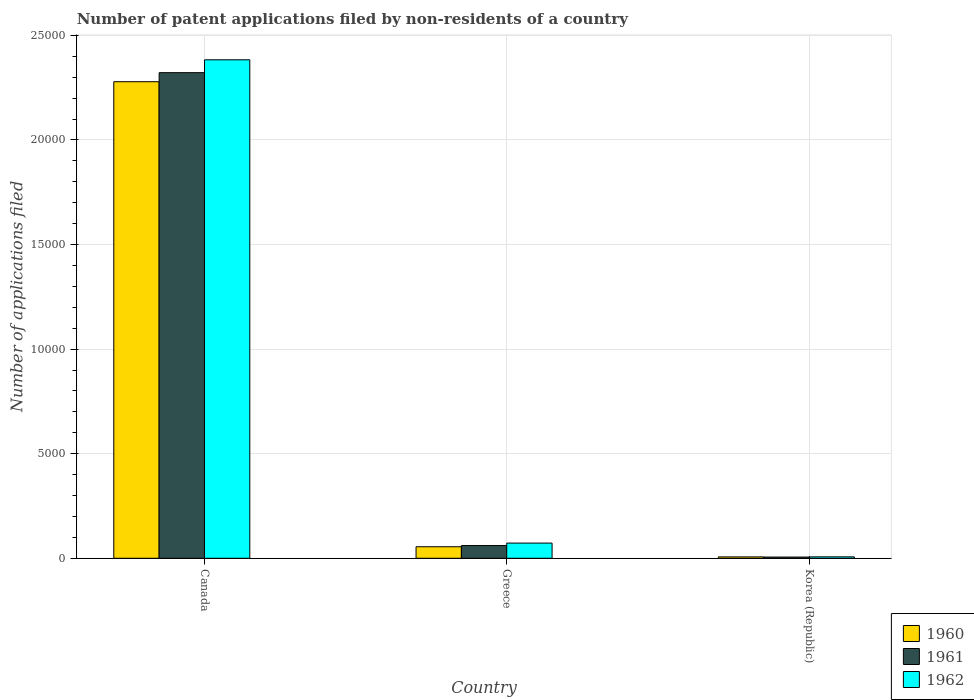How many different coloured bars are there?
Your answer should be compact. 3. How many groups of bars are there?
Your answer should be compact. 3. Are the number of bars per tick equal to the number of legend labels?
Offer a terse response. Yes. How many bars are there on the 3rd tick from the left?
Offer a terse response. 3. What is the number of applications filed in 1960 in Greece?
Make the answer very short. 551. Across all countries, what is the maximum number of applications filed in 1962?
Offer a terse response. 2.38e+04. In which country was the number of applications filed in 1961 minimum?
Your response must be concise. Korea (Republic). What is the total number of applications filed in 1960 in the graph?
Your answer should be compact. 2.34e+04. What is the difference between the number of applications filed in 1960 in Greece and that in Korea (Republic)?
Provide a succinct answer. 485. What is the difference between the number of applications filed in 1961 in Greece and the number of applications filed in 1962 in Korea (Republic)?
Offer a terse response. 541. What is the average number of applications filed in 1962 per country?
Provide a short and direct response. 8209.33. What is the difference between the number of applications filed of/in 1961 and number of applications filed of/in 1962 in Greece?
Provide a succinct answer. -117. In how many countries, is the number of applications filed in 1961 greater than 10000?
Offer a very short reply. 1. What is the ratio of the number of applications filed in 1961 in Canada to that in Korea (Republic)?
Offer a terse response. 400.33. What is the difference between the highest and the second highest number of applications filed in 1961?
Provide a succinct answer. 551. What is the difference between the highest and the lowest number of applications filed in 1961?
Give a very brief answer. 2.32e+04. In how many countries, is the number of applications filed in 1961 greater than the average number of applications filed in 1961 taken over all countries?
Ensure brevity in your answer.  1. What does the 2nd bar from the left in Korea (Republic) represents?
Offer a very short reply. 1961. What does the 2nd bar from the right in Greece represents?
Your answer should be compact. 1961. Is it the case that in every country, the sum of the number of applications filed in 1962 and number of applications filed in 1960 is greater than the number of applications filed in 1961?
Provide a succinct answer. Yes. How many countries are there in the graph?
Your answer should be compact. 3. What is the difference between two consecutive major ticks on the Y-axis?
Your answer should be compact. 5000. Are the values on the major ticks of Y-axis written in scientific E-notation?
Give a very brief answer. No. Does the graph contain any zero values?
Keep it short and to the point. No. Where does the legend appear in the graph?
Your response must be concise. Bottom right. What is the title of the graph?
Provide a short and direct response. Number of patent applications filed by non-residents of a country. Does "1980" appear as one of the legend labels in the graph?
Your response must be concise. No. What is the label or title of the Y-axis?
Ensure brevity in your answer.  Number of applications filed. What is the Number of applications filed in 1960 in Canada?
Offer a terse response. 2.28e+04. What is the Number of applications filed in 1961 in Canada?
Ensure brevity in your answer.  2.32e+04. What is the Number of applications filed in 1962 in Canada?
Ensure brevity in your answer.  2.38e+04. What is the Number of applications filed in 1960 in Greece?
Make the answer very short. 551. What is the Number of applications filed of 1961 in Greece?
Your answer should be compact. 609. What is the Number of applications filed in 1962 in Greece?
Offer a terse response. 726. What is the Number of applications filed in 1960 in Korea (Republic)?
Keep it short and to the point. 66. Across all countries, what is the maximum Number of applications filed in 1960?
Ensure brevity in your answer.  2.28e+04. Across all countries, what is the maximum Number of applications filed of 1961?
Offer a terse response. 2.32e+04. Across all countries, what is the maximum Number of applications filed in 1962?
Ensure brevity in your answer.  2.38e+04. What is the total Number of applications filed of 1960 in the graph?
Keep it short and to the point. 2.34e+04. What is the total Number of applications filed in 1961 in the graph?
Give a very brief answer. 2.39e+04. What is the total Number of applications filed in 1962 in the graph?
Offer a very short reply. 2.46e+04. What is the difference between the Number of applications filed of 1960 in Canada and that in Greece?
Offer a terse response. 2.22e+04. What is the difference between the Number of applications filed of 1961 in Canada and that in Greece?
Keep it short and to the point. 2.26e+04. What is the difference between the Number of applications filed in 1962 in Canada and that in Greece?
Give a very brief answer. 2.31e+04. What is the difference between the Number of applications filed in 1960 in Canada and that in Korea (Republic)?
Ensure brevity in your answer.  2.27e+04. What is the difference between the Number of applications filed of 1961 in Canada and that in Korea (Republic)?
Your answer should be very brief. 2.32e+04. What is the difference between the Number of applications filed in 1962 in Canada and that in Korea (Republic)?
Your answer should be very brief. 2.38e+04. What is the difference between the Number of applications filed of 1960 in Greece and that in Korea (Republic)?
Provide a succinct answer. 485. What is the difference between the Number of applications filed in 1961 in Greece and that in Korea (Republic)?
Your answer should be compact. 551. What is the difference between the Number of applications filed in 1962 in Greece and that in Korea (Republic)?
Give a very brief answer. 658. What is the difference between the Number of applications filed in 1960 in Canada and the Number of applications filed in 1961 in Greece?
Your answer should be very brief. 2.22e+04. What is the difference between the Number of applications filed in 1960 in Canada and the Number of applications filed in 1962 in Greece?
Your response must be concise. 2.21e+04. What is the difference between the Number of applications filed in 1961 in Canada and the Number of applications filed in 1962 in Greece?
Provide a short and direct response. 2.25e+04. What is the difference between the Number of applications filed in 1960 in Canada and the Number of applications filed in 1961 in Korea (Republic)?
Ensure brevity in your answer.  2.27e+04. What is the difference between the Number of applications filed of 1960 in Canada and the Number of applications filed of 1962 in Korea (Republic)?
Give a very brief answer. 2.27e+04. What is the difference between the Number of applications filed of 1961 in Canada and the Number of applications filed of 1962 in Korea (Republic)?
Provide a succinct answer. 2.32e+04. What is the difference between the Number of applications filed of 1960 in Greece and the Number of applications filed of 1961 in Korea (Republic)?
Give a very brief answer. 493. What is the difference between the Number of applications filed in 1960 in Greece and the Number of applications filed in 1962 in Korea (Republic)?
Your response must be concise. 483. What is the difference between the Number of applications filed of 1961 in Greece and the Number of applications filed of 1962 in Korea (Republic)?
Make the answer very short. 541. What is the average Number of applications filed of 1960 per country?
Offer a very short reply. 7801. What is the average Number of applications filed of 1961 per country?
Your response must be concise. 7962. What is the average Number of applications filed in 1962 per country?
Ensure brevity in your answer.  8209.33. What is the difference between the Number of applications filed of 1960 and Number of applications filed of 1961 in Canada?
Give a very brief answer. -433. What is the difference between the Number of applications filed in 1960 and Number of applications filed in 1962 in Canada?
Offer a very short reply. -1048. What is the difference between the Number of applications filed of 1961 and Number of applications filed of 1962 in Canada?
Your answer should be very brief. -615. What is the difference between the Number of applications filed of 1960 and Number of applications filed of 1961 in Greece?
Give a very brief answer. -58. What is the difference between the Number of applications filed in 1960 and Number of applications filed in 1962 in Greece?
Your answer should be compact. -175. What is the difference between the Number of applications filed in 1961 and Number of applications filed in 1962 in Greece?
Provide a succinct answer. -117. What is the difference between the Number of applications filed in 1961 and Number of applications filed in 1962 in Korea (Republic)?
Offer a very short reply. -10. What is the ratio of the Number of applications filed of 1960 in Canada to that in Greece?
Keep it short and to the point. 41.35. What is the ratio of the Number of applications filed of 1961 in Canada to that in Greece?
Your answer should be compact. 38.13. What is the ratio of the Number of applications filed in 1962 in Canada to that in Greece?
Provide a short and direct response. 32.83. What is the ratio of the Number of applications filed of 1960 in Canada to that in Korea (Republic)?
Offer a terse response. 345.24. What is the ratio of the Number of applications filed in 1961 in Canada to that in Korea (Republic)?
Your answer should be very brief. 400.33. What is the ratio of the Number of applications filed of 1962 in Canada to that in Korea (Republic)?
Your answer should be very brief. 350.5. What is the ratio of the Number of applications filed in 1960 in Greece to that in Korea (Republic)?
Provide a short and direct response. 8.35. What is the ratio of the Number of applications filed of 1961 in Greece to that in Korea (Republic)?
Offer a terse response. 10.5. What is the ratio of the Number of applications filed in 1962 in Greece to that in Korea (Republic)?
Make the answer very short. 10.68. What is the difference between the highest and the second highest Number of applications filed in 1960?
Your response must be concise. 2.22e+04. What is the difference between the highest and the second highest Number of applications filed of 1961?
Make the answer very short. 2.26e+04. What is the difference between the highest and the second highest Number of applications filed in 1962?
Keep it short and to the point. 2.31e+04. What is the difference between the highest and the lowest Number of applications filed in 1960?
Offer a very short reply. 2.27e+04. What is the difference between the highest and the lowest Number of applications filed of 1961?
Make the answer very short. 2.32e+04. What is the difference between the highest and the lowest Number of applications filed of 1962?
Make the answer very short. 2.38e+04. 